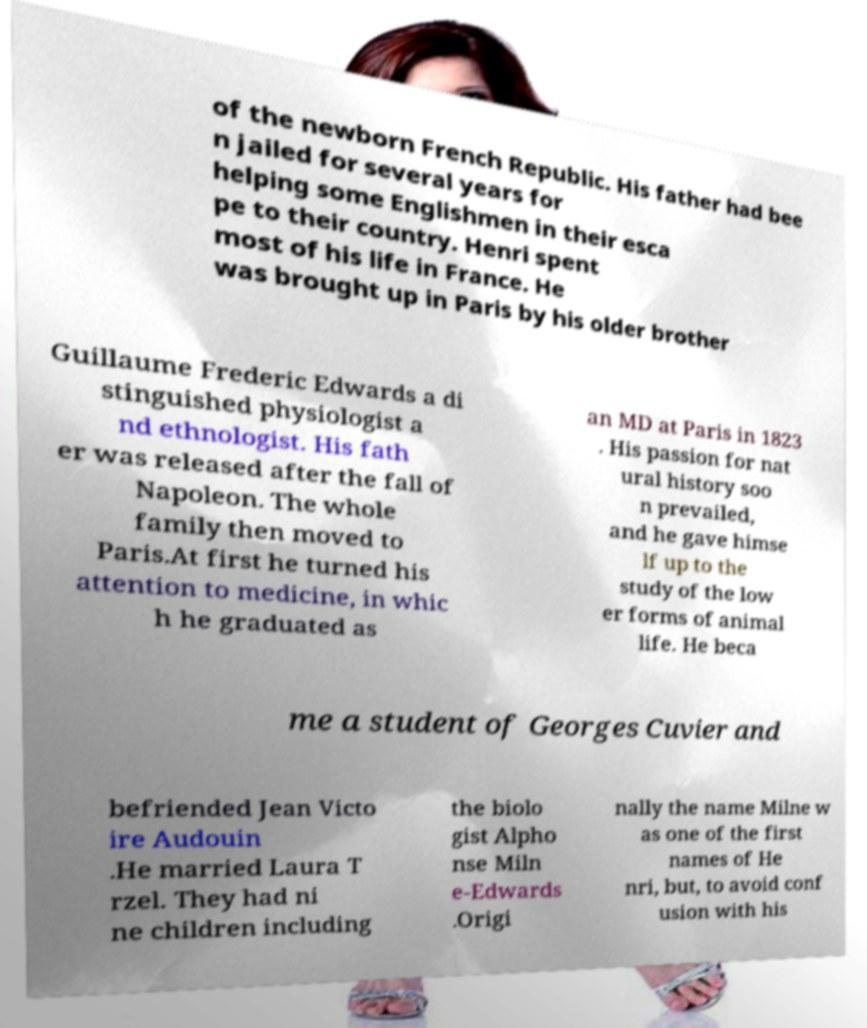What messages or text are displayed in this image? I need them in a readable, typed format. of the newborn French Republic. His father had bee n jailed for several years for helping some Englishmen in their esca pe to their country. Henri spent most of his life in France. He was brought up in Paris by his older brother Guillaume Frederic Edwards a di stinguished physiologist a nd ethnologist. His fath er was released after the fall of Napoleon. The whole family then moved to Paris.At first he turned his attention to medicine, in whic h he graduated as an MD at Paris in 1823 . His passion for nat ural history soo n prevailed, and he gave himse lf up to the study of the low er forms of animal life. He beca me a student of Georges Cuvier and befriended Jean Victo ire Audouin .He married Laura T rzel. They had ni ne children including the biolo gist Alpho nse Miln e-Edwards .Origi nally the name Milne w as one of the first names of He nri, but, to avoid conf usion with his 